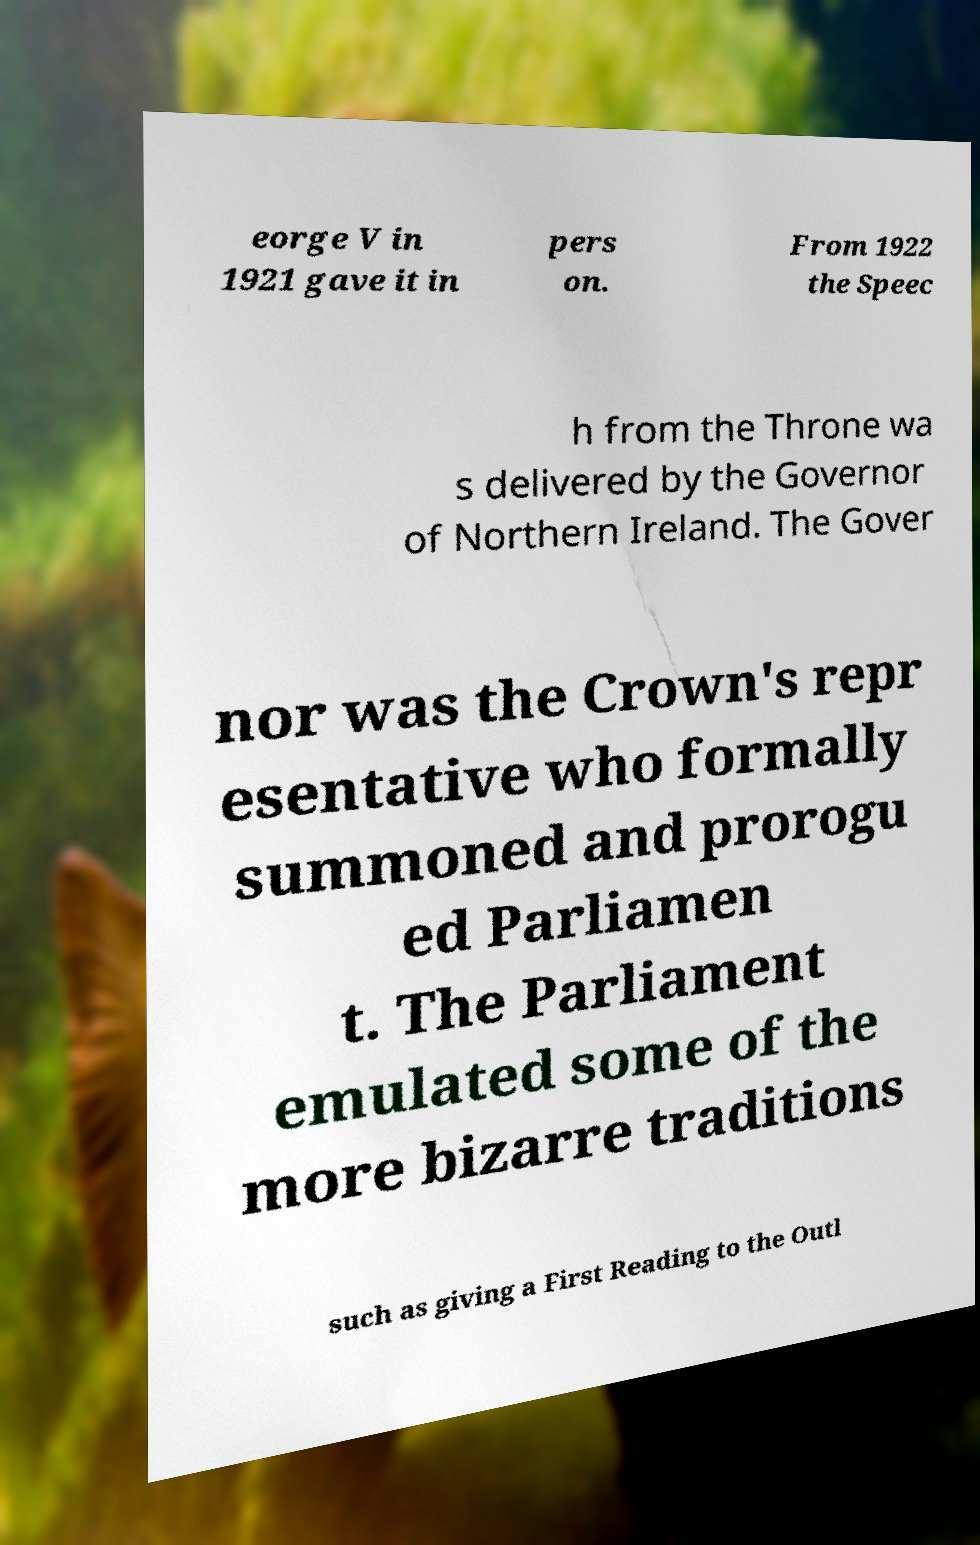Could you assist in decoding the text presented in this image and type it out clearly? eorge V in 1921 gave it in pers on. From 1922 the Speec h from the Throne wa s delivered by the Governor of Northern Ireland. The Gover nor was the Crown's repr esentative who formally summoned and prorogu ed Parliamen t. The Parliament emulated some of the more bizarre traditions such as giving a First Reading to the Outl 